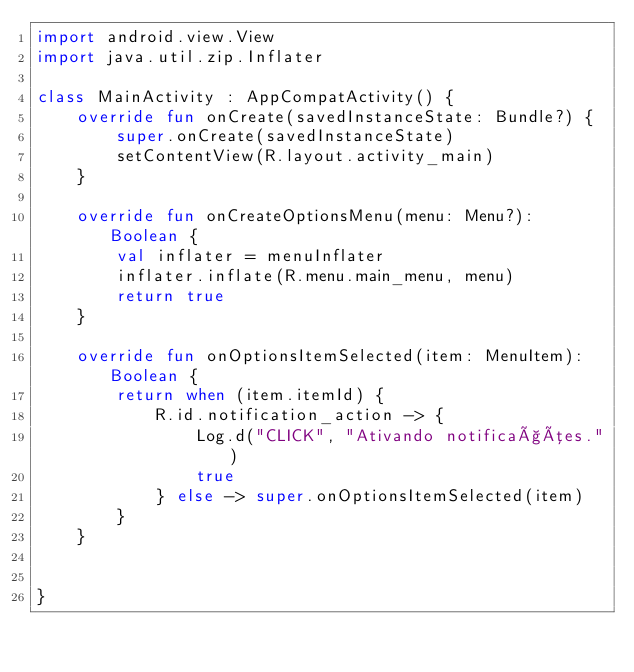Convert code to text. <code><loc_0><loc_0><loc_500><loc_500><_Kotlin_>import android.view.View
import java.util.zip.Inflater

class MainActivity : AppCompatActivity() {
    override fun onCreate(savedInstanceState: Bundle?) {
        super.onCreate(savedInstanceState)
        setContentView(R.layout.activity_main)
    }

    override fun onCreateOptionsMenu(menu: Menu?): Boolean {
        val inflater = menuInflater
        inflater.inflate(R.menu.main_menu, menu)
        return true
    }

    override fun onOptionsItemSelected(item: MenuItem): Boolean {
        return when (item.itemId) {
            R.id.notification_action -> {
                Log.d("CLICK", "Ativando notificações.")
                true
            } else -> super.onOptionsItemSelected(item)
        }
    }


}</code> 